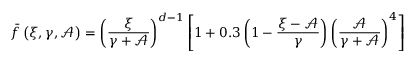Convert formula to latex. <formula><loc_0><loc_0><loc_500><loc_500>\bar { f } \left ( \xi , \gamma , \mathcal { A } \right ) = \left ( \frac { \xi } { \gamma + \mathcal { A } } \right ) ^ { d - 1 } \left [ 1 + 0 . 3 \left ( 1 - \frac { \xi - \mathcal { A } } { \gamma } \right ) \left ( \frac { \mathcal { A } } { \gamma + \mathcal { A } } \right ) ^ { 4 } \right ]</formula> 